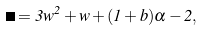<formula> <loc_0><loc_0><loc_500><loc_500>\Gamma = 3 w ^ { 2 } + w + ( 1 + b ) \alpha - 2 ,</formula> 